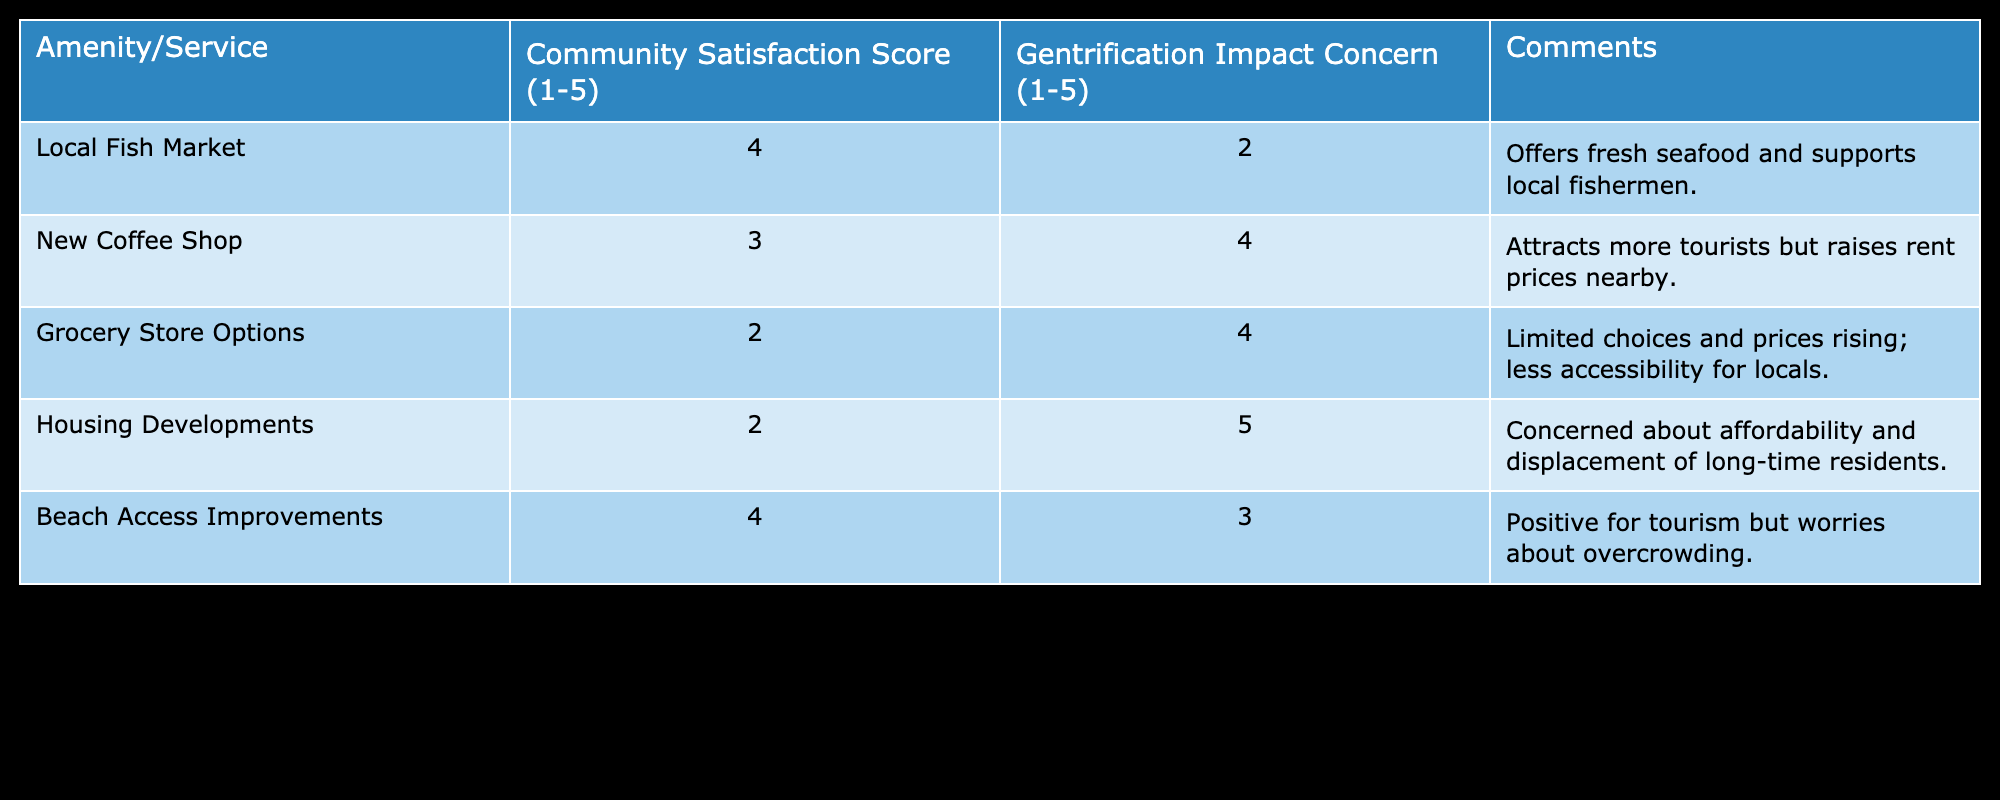What is the community satisfaction score for the Local Fish Market? The table shows the score directly next to the Local Fish Market under the "Community Satisfaction Score" column, which is 4.
Answer: 4 What concern level is associated with the New Coffee Shop? For the New Coffee Shop, the "Gentrification Impact Concern" score is found in the table, which indicates a value of 4.
Answer: 4 Which amenity has the highest satisfaction score? Looking through the "Community Satisfaction Score" column, the highest score is 4, which is tied between the Local Fish Market and Beach Access Improvements.
Answer: Local Fish Market and Beach Access Improvements What is the average community satisfaction score for all amenities and services? First, sum the satisfaction scores: 4 (Local Fish Market) + 3 (New Coffee Shop) + 2 (Grocery Store Options) + 2 (Housing Developments) + 4 (Beach Access Improvements) = 15. Then, divide by the number of amenities (5): 15/5 = 3.
Answer: 3 Is the Grocery Store Options score higher than the Beach Access Improvements score? The Grocery Store Options score is 2 and the Beach Access Improvements score is 4. Thus, 2 is not higher than 4, meaning the statement is false.
Answer: No How many amenities and services have a concern level of 4 or higher regarding gentrification? By counting the Gentrification Impact Concern scores of 4 or more, we note that the New Coffee Shop and Grocery Store Options both have a concern of 4, and Housing Developments has a score of 5. This totals to 3 amenities/services.
Answer: 3 What is the difference in satisfaction scores between the Housing Developments and the Beach Access Improvements? The satisfaction score for Housing Developments is 2, and for Beach Access Improvements, it is 4. The difference is calculated as 4 - 2 = 2.
Answer: 2 Are there any amenities that have a concern level of 5 in the table? Checking the "Gentrification Impact Concern" column, only Housing Developments has a score of 5, indicating yes to the question.
Answer: Yes 